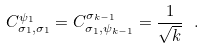<formula> <loc_0><loc_0><loc_500><loc_500>C _ { \sigma _ { 1 } , \sigma _ { 1 } } ^ { \psi _ { 1 } } = C _ { \sigma _ { 1 } , \psi _ { k - 1 } } ^ { \sigma _ { k - 1 } } = \frac { 1 } { \sqrt { k } } \ .</formula> 